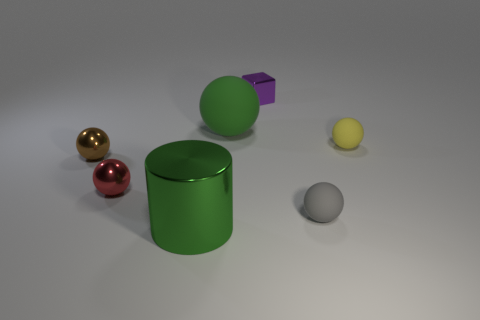Subtract all yellow balls. How many balls are left? 4 Subtract all tiny yellow rubber balls. How many balls are left? 4 Subtract 1 balls. How many balls are left? 4 Subtract all cyan balls. Subtract all red cylinders. How many balls are left? 5 Add 1 small brown objects. How many objects exist? 8 Subtract all cylinders. How many objects are left? 6 Subtract 1 green spheres. How many objects are left? 6 Subtract all big cylinders. Subtract all big yellow cylinders. How many objects are left? 6 Add 5 big green objects. How many big green objects are left? 7 Add 3 matte blocks. How many matte blocks exist? 3 